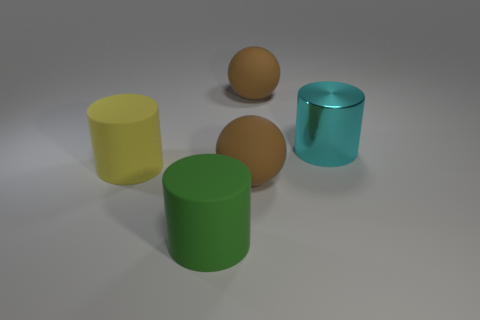What number of objects are either big purple shiny cylinders or big cylinders that are in front of the big cyan metallic object?
Your answer should be compact. 2. What is the color of the large rubber cylinder that is in front of the cylinder that is on the left side of the cylinder in front of the large yellow cylinder?
Give a very brief answer. Green. There is a rubber cylinder that is to the right of the big yellow matte object; how big is it?
Ensure brevity in your answer.  Large. How many small things are either brown spheres or cyan metal objects?
Give a very brief answer. 0. What color is the big thing that is behind the yellow thing and left of the cyan thing?
Your response must be concise. Brown. Is there another big metal object that has the same shape as the yellow thing?
Provide a short and direct response. Yes. What is the material of the yellow cylinder?
Your answer should be compact. Rubber. Are there any yellow things on the left side of the large shiny thing?
Give a very brief answer. Yes. Does the green rubber object have the same shape as the yellow object?
Provide a succinct answer. Yes. What number of other things are there of the same size as the green thing?
Make the answer very short. 4. 